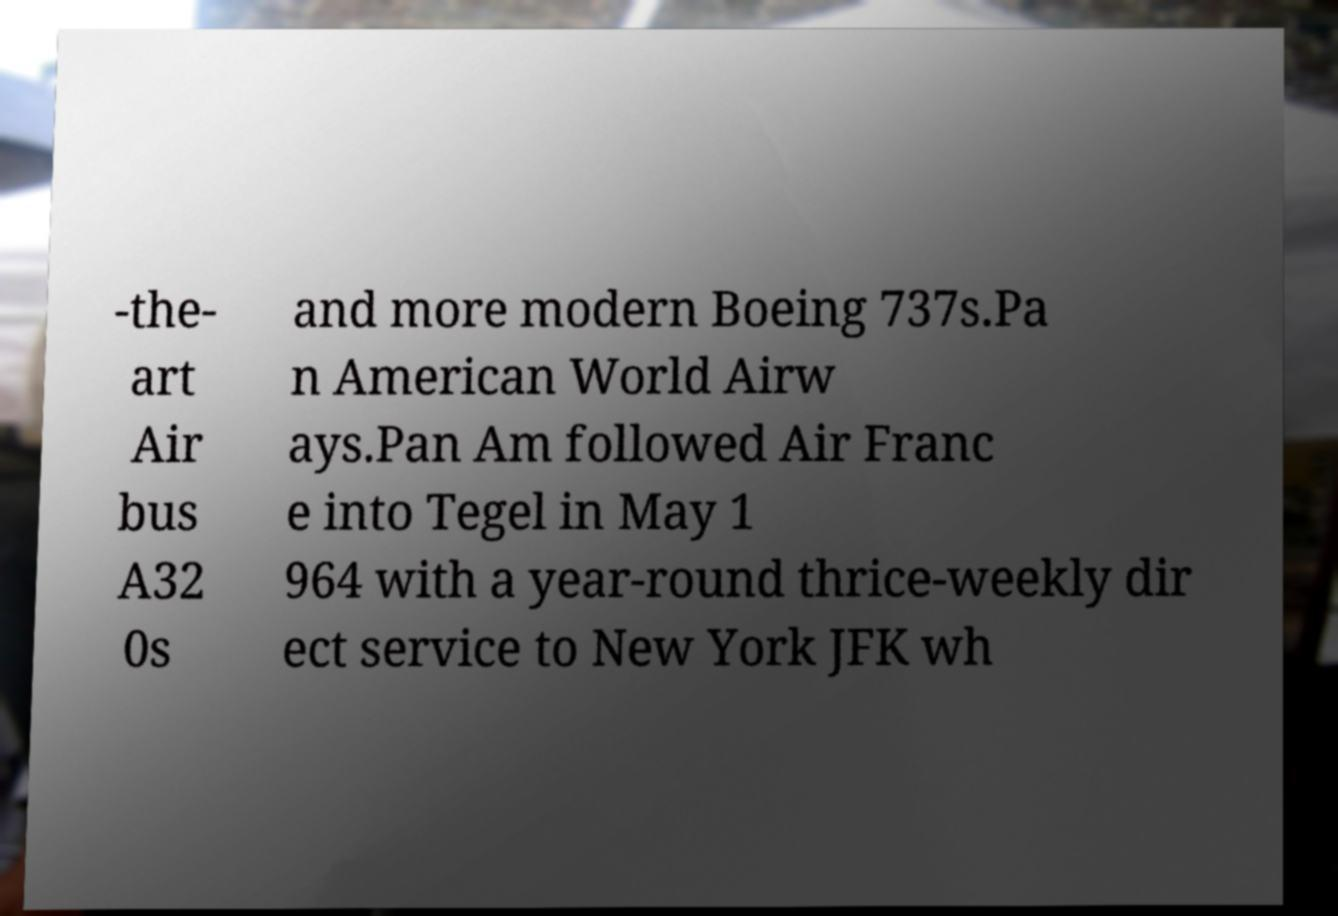I need the written content from this picture converted into text. Can you do that? -the- art Air bus A32 0s and more modern Boeing 737s.Pa n American World Airw ays.Pan Am followed Air Franc e into Tegel in May 1 964 with a year-round thrice-weekly dir ect service to New York JFK wh 